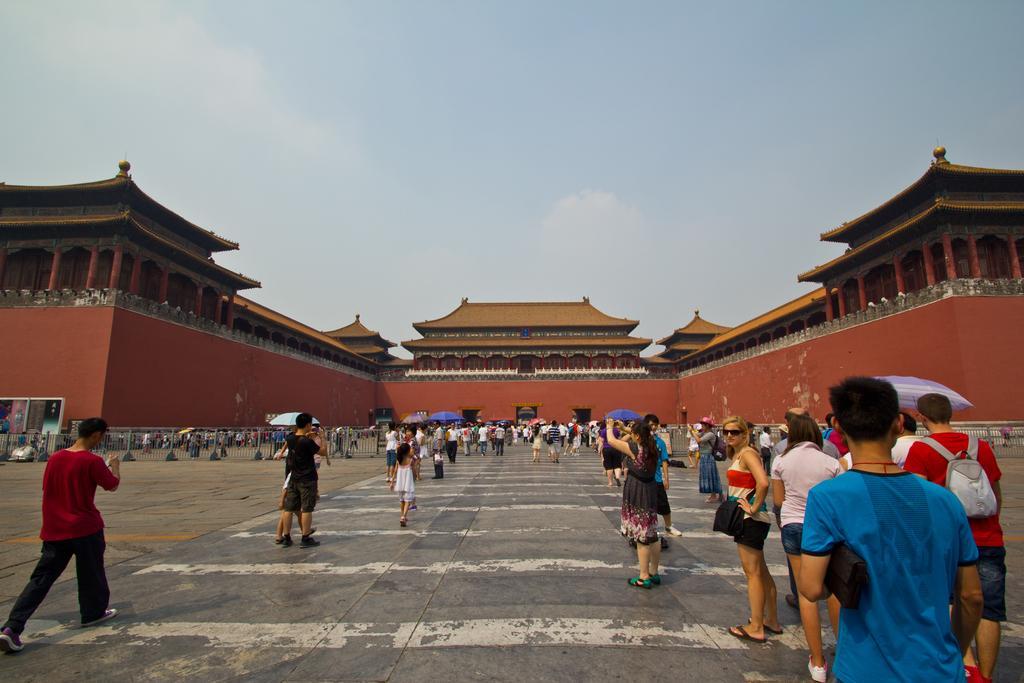How would you summarize this image in a sentence or two? In this picture we can see many persons standing in the ground and taking photographs. Behind there is a Buddha temple and roof tiles on the top. 